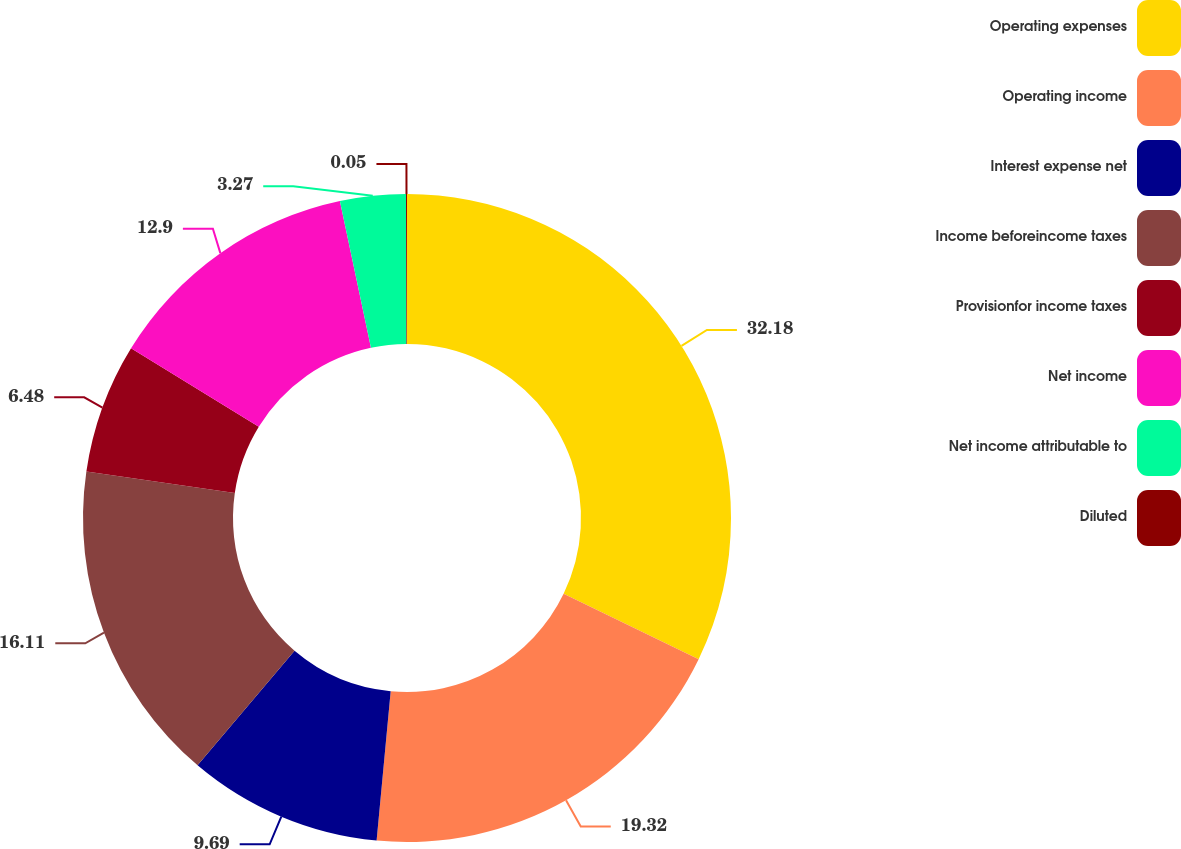Convert chart. <chart><loc_0><loc_0><loc_500><loc_500><pie_chart><fcel>Operating expenses<fcel>Operating income<fcel>Interest expense net<fcel>Income beforeincome taxes<fcel>Provisionfor income taxes<fcel>Net income<fcel>Net income attributable to<fcel>Diluted<nl><fcel>32.17%<fcel>19.32%<fcel>9.69%<fcel>16.11%<fcel>6.48%<fcel>12.9%<fcel>3.27%<fcel>0.05%<nl></chart> 